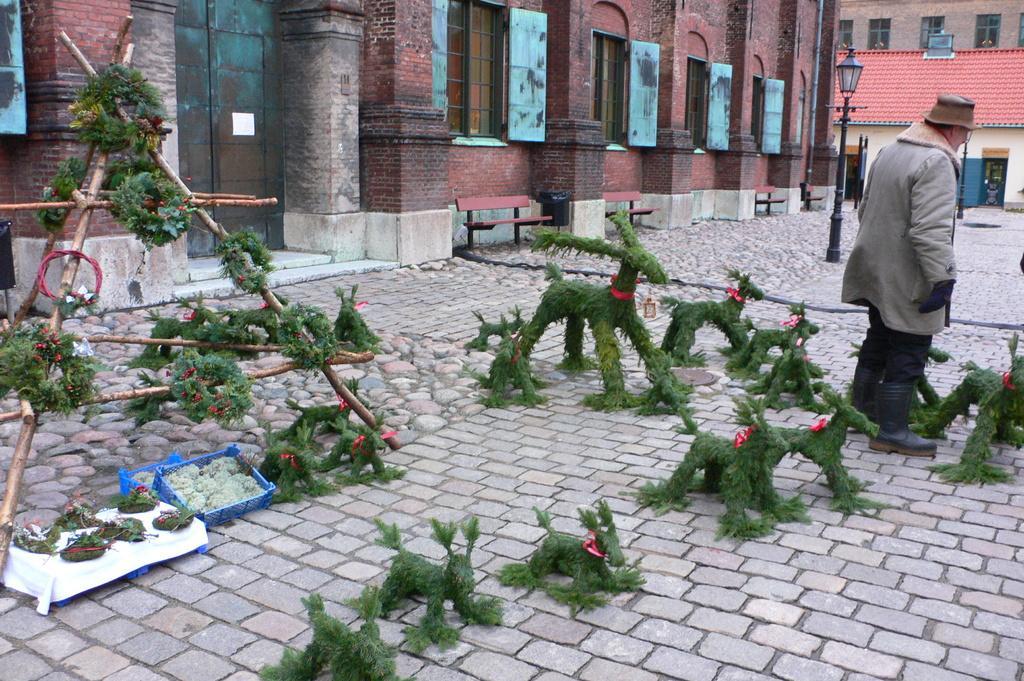Please provide a concise description of this image. In this picture there is a man who is standing near to the toys. On the floor I can see many green toys. In the back I can see the building, shed, street light and benches. On the top left I can see the windows and door. 